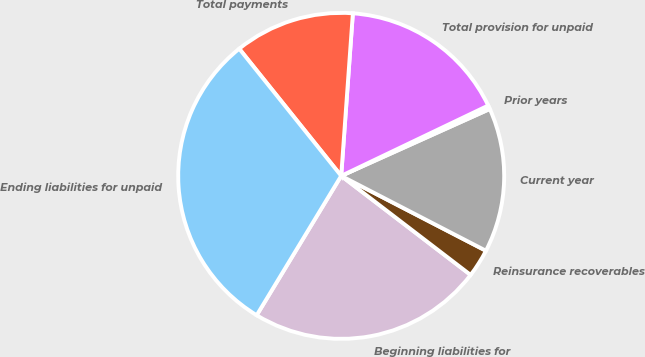Convert chart to OTSL. <chart><loc_0><loc_0><loc_500><loc_500><pie_chart><fcel>Beginning liabilities for<fcel>Reinsurance recoverables<fcel>Current year<fcel>Prior years<fcel>Total provision for unpaid<fcel>Total payments<fcel>Ending liabilities for unpaid<nl><fcel>23.28%<fcel>2.8%<fcel>14.33%<fcel>0.37%<fcel>16.76%<fcel>11.9%<fcel>30.57%<nl></chart> 